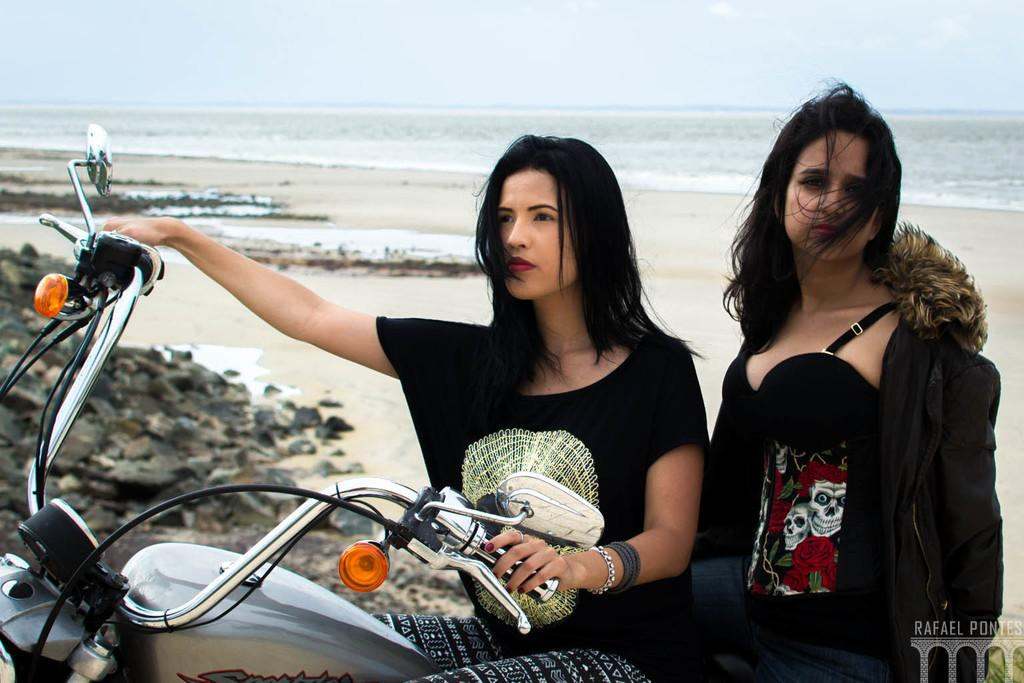What is the woman doing in the image? The woman is sitting on a motorbike. What is the woman wearing on her upper body? The woman is wearing a black jacket and a black t-shirt. What type of water body can be seen in the image? There is a freshwater river in the image. What type of natural feature is visible in the image? There are stones visible in the image. What color is the blood on the stones in the image? There is no blood present in the image; it only features a woman sitting on a motorbike, a freshwater river, and stones. 